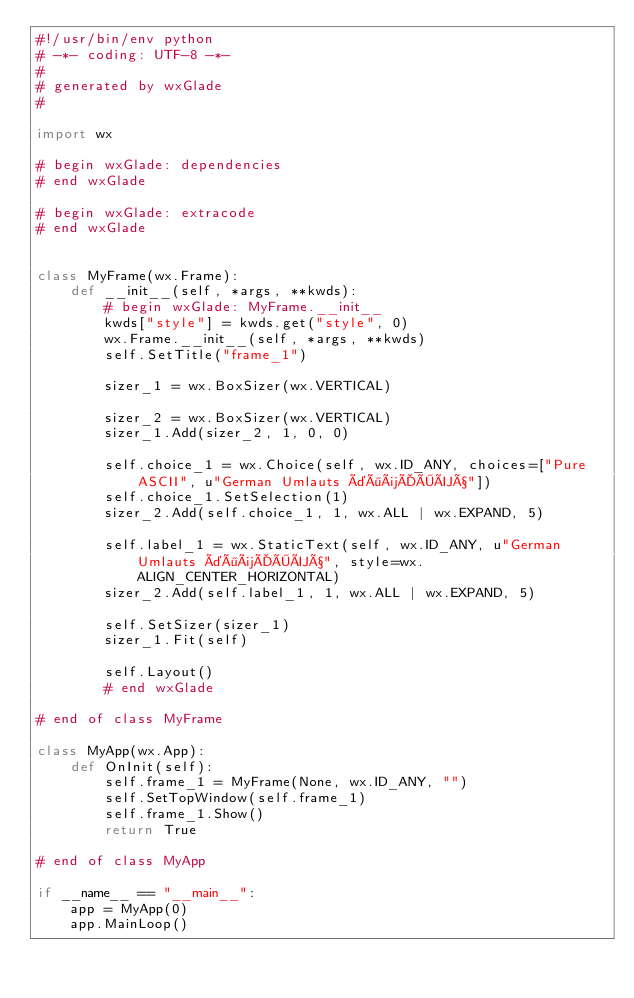<code> <loc_0><loc_0><loc_500><loc_500><_Python_>#!/usr/bin/env python
# -*- coding: UTF-8 -*-
#
# generated by wxGlade
#

import wx

# begin wxGlade: dependencies
# end wxGlade

# begin wxGlade: extracode
# end wxGlade


class MyFrame(wx.Frame):
    def __init__(self, *args, **kwds):
        # begin wxGlade: MyFrame.__init__
        kwds["style"] = kwds.get("style", 0)
        wx.Frame.__init__(self, *args, **kwds)
        self.SetTitle("frame_1")

        sizer_1 = wx.BoxSizer(wx.VERTICAL)

        sizer_2 = wx.BoxSizer(wx.VERTICAL)
        sizer_1.Add(sizer_2, 1, 0, 0)

        self.choice_1 = wx.Choice(self, wx.ID_ANY, choices=["Pure ASCII", u"German Umlauts äöüÄÖÜß"])
        self.choice_1.SetSelection(1)
        sizer_2.Add(self.choice_1, 1, wx.ALL | wx.EXPAND, 5)

        self.label_1 = wx.StaticText(self, wx.ID_ANY, u"German Umlauts äöüÄÖÜß", style=wx.ALIGN_CENTER_HORIZONTAL)
        sizer_2.Add(self.label_1, 1, wx.ALL | wx.EXPAND, 5)

        self.SetSizer(sizer_1)
        sizer_1.Fit(self)

        self.Layout()
        # end wxGlade

# end of class MyFrame

class MyApp(wx.App):
    def OnInit(self):
        self.frame_1 = MyFrame(None, wx.ID_ANY, "")
        self.SetTopWindow(self.frame_1)
        self.frame_1.Show()
        return True

# end of class MyApp

if __name__ == "__main__":
    app = MyApp(0)
    app.MainLoop()
</code> 